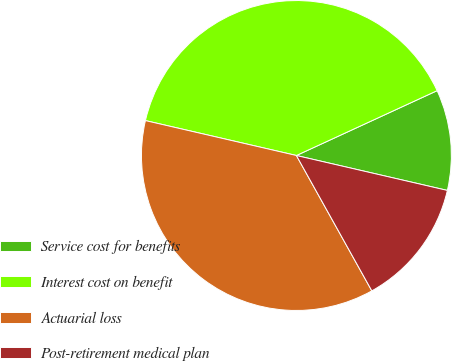Convert chart. <chart><loc_0><loc_0><loc_500><loc_500><pie_chart><fcel>Service cost for benefits<fcel>Interest cost on benefit<fcel>Actuarial loss<fcel>Post-retirement medical plan<nl><fcel>10.49%<fcel>39.51%<fcel>36.71%<fcel>13.29%<nl></chart> 